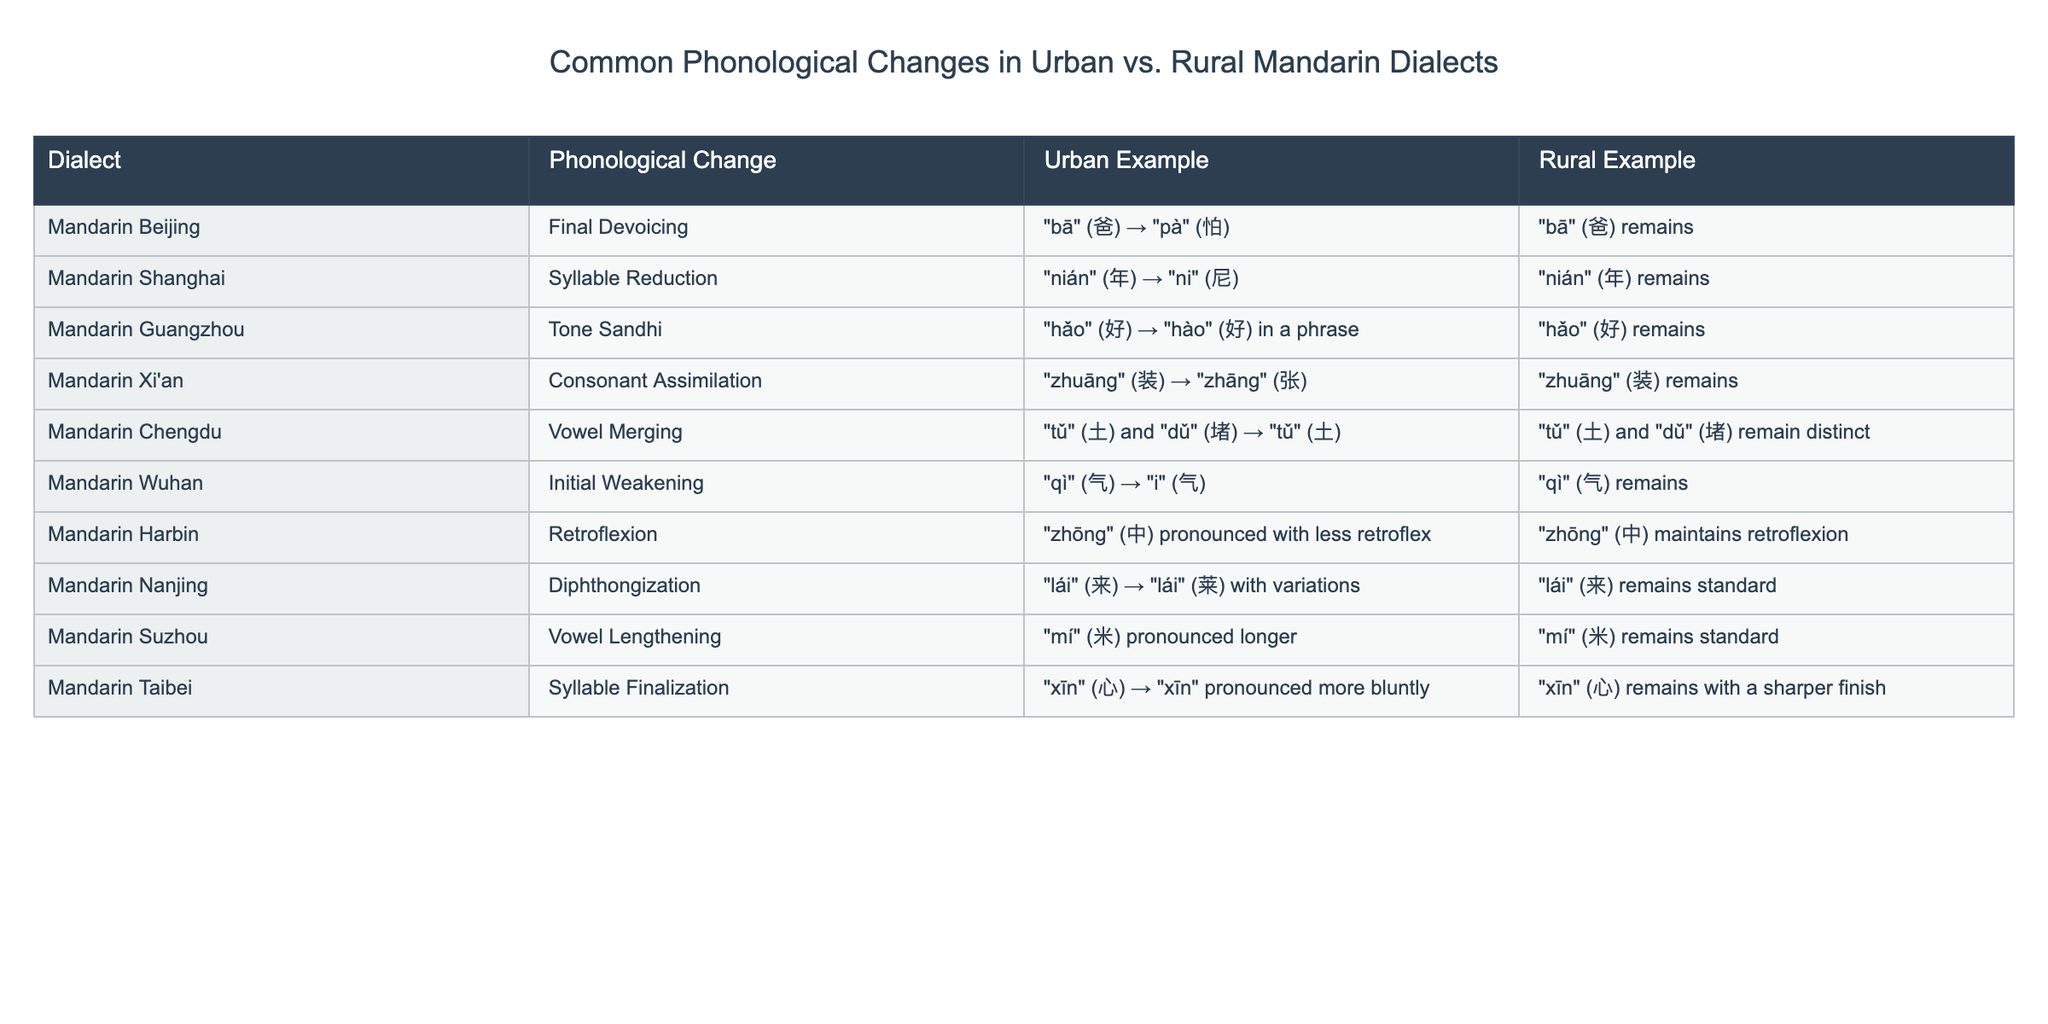What phonological change is observed in Mandarin Beijing? According to the table, the phonological change in Mandarin Beijing is final devoicing.
Answer: Final Devoicing Which urban dialect demonstrates vowel merging? The table indicates that Mandarin Chengdu exhibits vowel merging.
Answer: Mandarin Chengdu In which rural dialect does the phonological change of retroflexion occur? The table shows that Mandarin Harbin has a phonological change related to retroflexion in the urban dialect, not rural.
Answer: No rural dialect shows retroflexion What is an urban example of tone sandhi? The urban example of tone sandhi presented in the table is "hǎo" (好) pronounced as "hào" (好) in a phrase in Mandarin Guangzhou.
Answer: "hǎo" → "hào" in Mandarin Guangzhou Which urban dialect allows for initial weakening? According to the table, Mandarin Wuhan shows initial weakening as an urban phonological change.
Answer: Mandarin Wuhan What phonological change relates to syllable reduction, and in which urban dialect is it observed? The observed phonological change is syllable reduction, as seen in Mandarin Shanghai with the example "nián" changing to "ni".
Answer: Syllable reduction in Mandarin Shanghai Does any rural dialect show initial weakening? The table illustrates that initial weakening is not observed in any rural dialect; it only appears in Mandarin Wuhan as an urban example.
Answer: No Which urban dialect demonstrates consonant assimilation? The table shows that consonant assimilation is present in Mandarin Xi'an.
Answer: Mandarin Xi'an How many phonological changes do the urban Mandarin dialects demonstrate compared to the rural ones? The table lists 10 phonological changes, with 8 in urban dialects and 2 in rural dialects, indicating a higher prevalence in urban settings.
Answer: 6 more changes in urban dialects Explain how the vowel lengthening change is manifested in urban dialects. The table explains that in urban Suzhou, "mí" (米) is pronounced longer than the standard, indicating a phonological change towards vowel lengthening.
Answer: Longer pronunciation in Suzhou What is the example of diphthongization and what is its urban dialect? The table describes diphthongization observed in "lái" (来) pronounced with variations in Mandarin Nanjing.
Answer: Example is "lái" in Mandarin Nanjing 